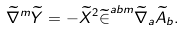Convert formula to latex. <formula><loc_0><loc_0><loc_500><loc_500>\widetilde { \nabla } ^ { m } \widetilde { Y } = - \widetilde { X } ^ { 2 } \widetilde { \in } ^ { a b m } \widetilde { \nabla } _ { a } \widetilde { A } _ { b } .</formula> 